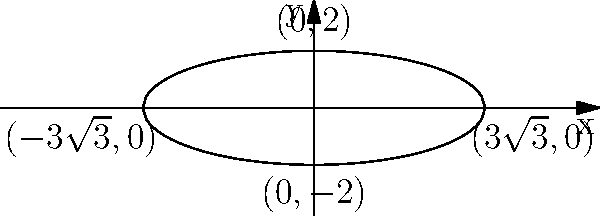As a hairstylist creating an elegant bridal updo, you're inspired by the shape of a conic section. The general equation of this conic is given by $\frac{x^2}{27} + \frac{y^2}{4} = 1$. Identify the type of conic section this represents and sketch its graph, labeling key points that could represent the placement of decorative hairpins in your updo design. To identify the conic section and sketch its graph, we'll follow these steps:

1) First, let's recognize the standard form of the equation:
   $\frac{x^2}{a^2} + \frac{y^2}{b^2} = 1$

   This is the standard form of an ellipse.

2) From our equation $\frac{x^2}{27} + \frac{y^2}{4} = 1$, we can identify:
   $a^2 = 27$ and $b^2 = 4$

3) Therefore, $a = \sqrt{27} = 3\sqrt{3}$ and $b = 2$

4) The center of the ellipse is at (0,0) as there are no terms involving x or y alone.

5) To sketch the graph, we need to plot these key points:
   - The vertices on the x-axis: $(\pm a, 0) = (\pm 3\sqrt{3}, 0)$
   - The vertices on the y-axis: $(0, \pm b) = (0, \pm 2)$

6) The equation can be rewritten as:
   $y = \pm 2\sqrt{1 - \frac{x^2}{27}}$

7) This is the equation we use to plot the ellipse.

The resulting graph shows an ellipse centered at the origin, with a horizontal major axis of length $6\sqrt{3}$ and a vertical minor axis of length 4. The four key points labeled could represent the ideal placement for decorative hairpins in a bridal updo, symmetrically arranged to complement the elegant shape of the hairstyle.
Answer: Ellipse centered at (0,0) with horizontal major axis $6\sqrt{3}$ and vertical minor axis 4 